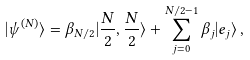Convert formula to latex. <formula><loc_0><loc_0><loc_500><loc_500>| \psi ^ { ( N ) } \rangle = \beta _ { N / 2 } | \frac { N } { 2 } , \frac { N } { 2 } \rangle + \sum _ { j = 0 } ^ { N / 2 - 1 } \beta _ { j } | e _ { j } \rangle \, ,</formula> 